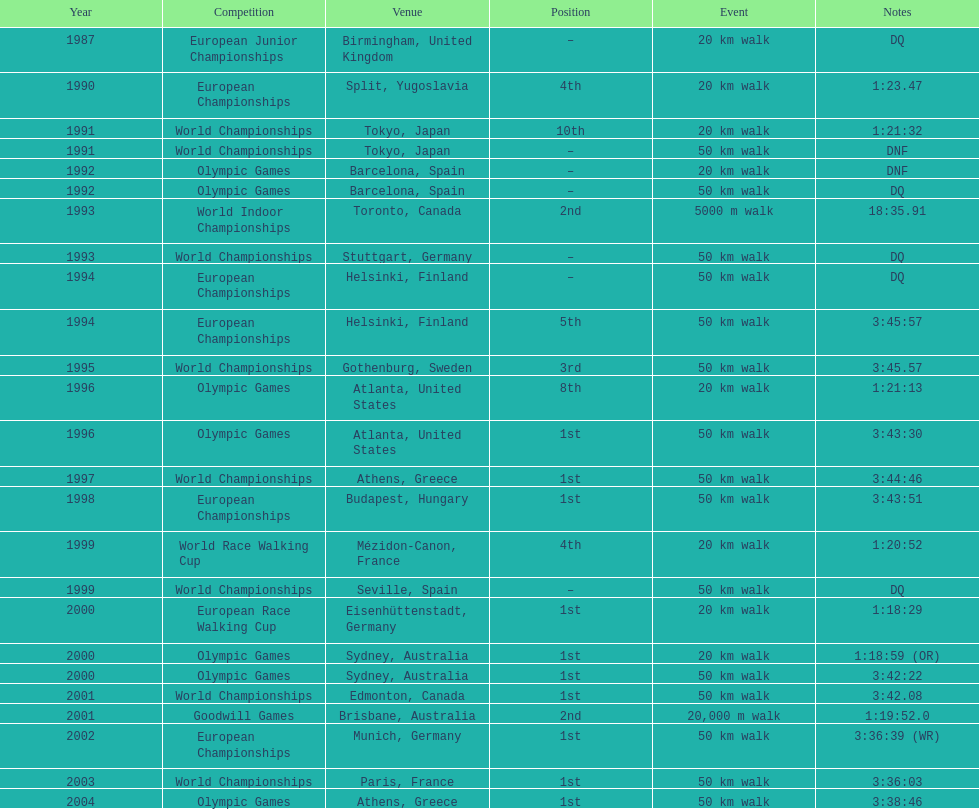Which place is cited the most? Athens, Greece. 